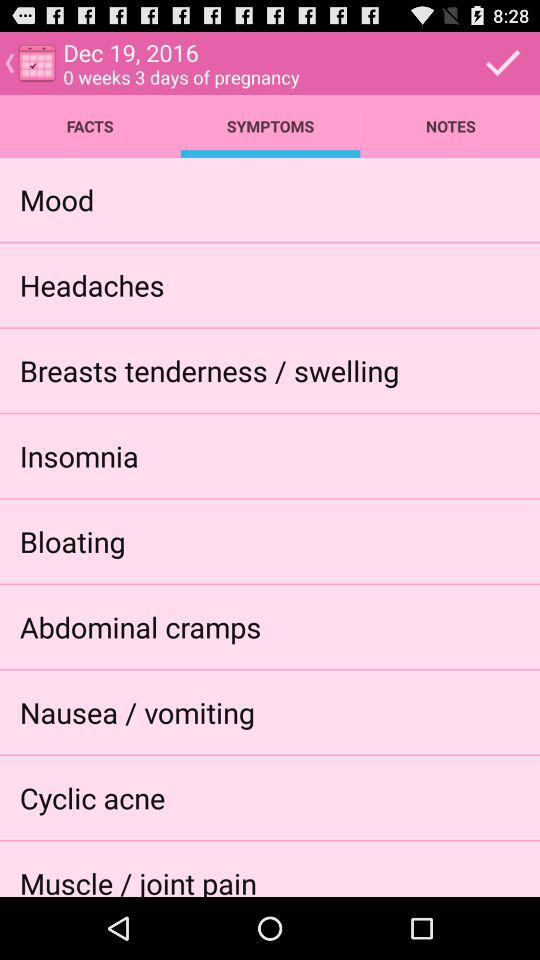How many symptoms do you have?
Answer the question using a single word or phrase. 9 